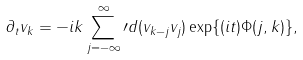Convert formula to latex. <formula><loc_0><loc_0><loc_500><loc_500>\partial _ { t } v _ { k } = - i k \sum _ { j = - \infty } ^ { \infty } \prime d ( v _ { k - j } v _ { j } ) \exp \{ ( i t ) \Phi ( j , k ) \} ,</formula> 